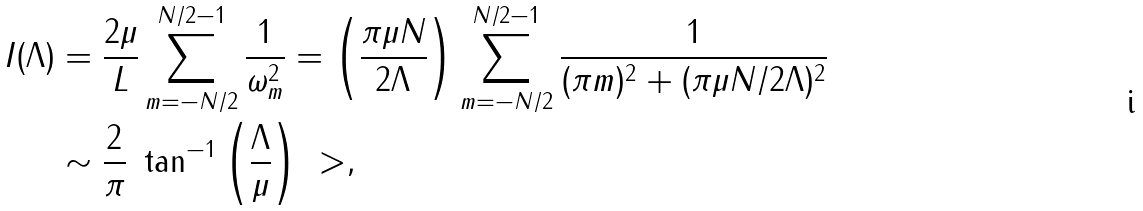Convert formula to latex. <formula><loc_0><loc_0><loc_500><loc_500>I ( \Lambda ) & = \frac { 2 \mu } { L } \sum _ { m = - N / 2 } ^ { N / 2 - 1 } \frac { 1 } { \omega _ { m } ^ { 2 } } = \left ( \frac { \pi \mu N } { 2 \Lambda } \right ) \sum _ { m = - N / 2 } ^ { N / 2 - 1 } \frac { 1 } { ( \pi m ) ^ { 2 } + ( \pi \mu N / 2 \Lambda ) ^ { 2 } } \\ & \sim \frac { 2 } { \pi } \ \tan ^ { - 1 } \left ( \frac { \Lambda } { \mu } \right ) \ > ,</formula> 